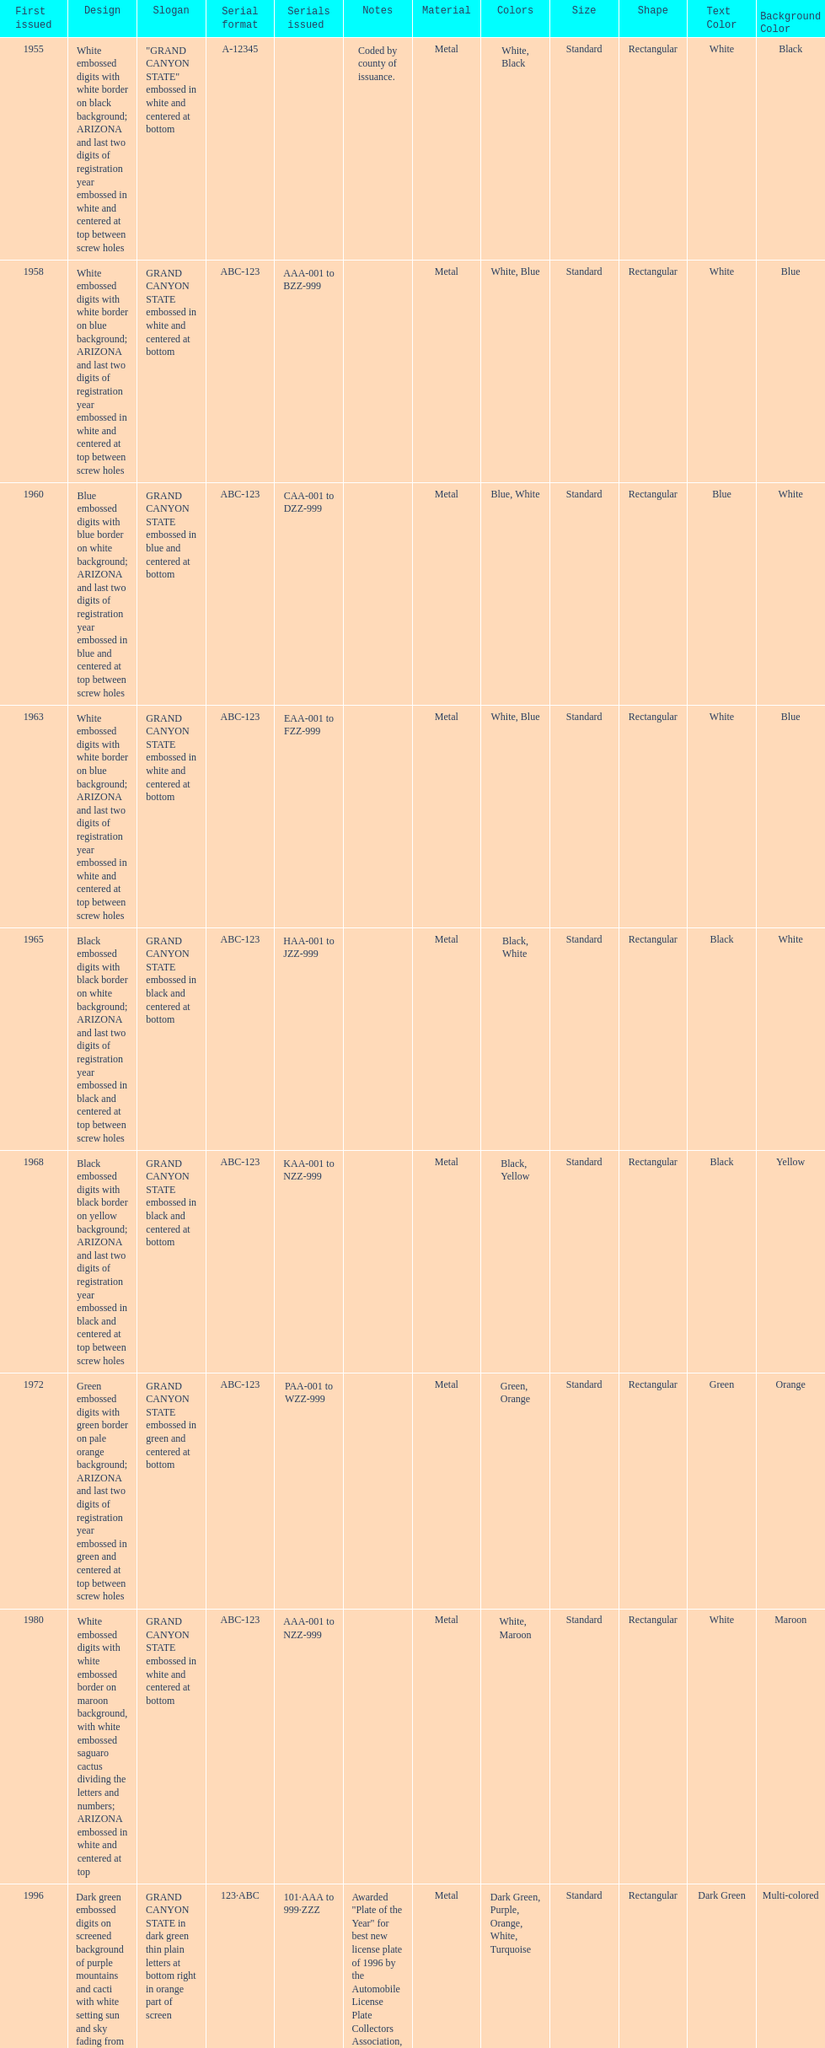What was year was the first arizona license plate made? 1955. 